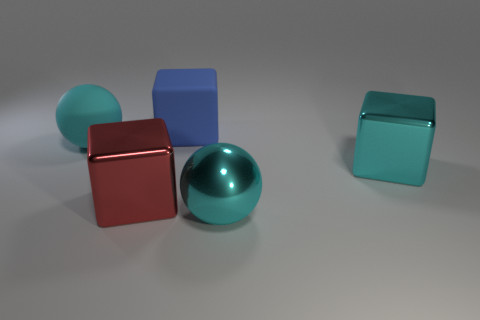Add 4 large cyan cubes. How many objects exist? 9 Subtract all blocks. How many objects are left? 2 Subtract 0 red cylinders. How many objects are left? 5 Subtract all large cyan things. Subtract all large cyan shiny cubes. How many objects are left? 1 Add 1 large cyan matte spheres. How many large cyan matte spheres are left? 2 Add 4 large objects. How many large objects exist? 9 